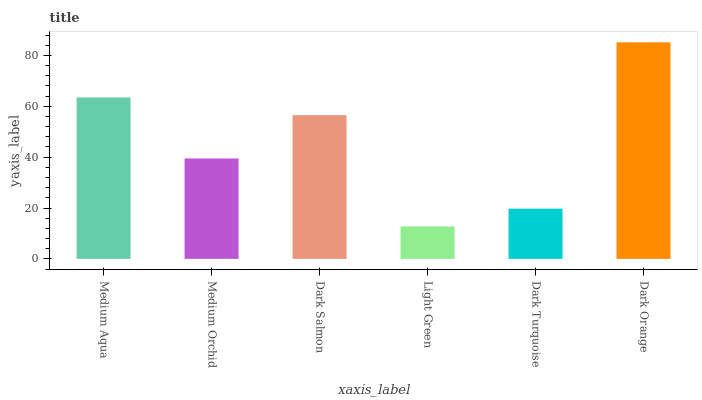Is Light Green the minimum?
Answer yes or no. Yes. Is Dark Orange the maximum?
Answer yes or no. Yes. Is Medium Orchid the minimum?
Answer yes or no. No. Is Medium Orchid the maximum?
Answer yes or no. No. Is Medium Aqua greater than Medium Orchid?
Answer yes or no. Yes. Is Medium Orchid less than Medium Aqua?
Answer yes or no. Yes. Is Medium Orchid greater than Medium Aqua?
Answer yes or no. No. Is Medium Aqua less than Medium Orchid?
Answer yes or no. No. Is Dark Salmon the high median?
Answer yes or no. Yes. Is Medium Orchid the low median?
Answer yes or no. Yes. Is Medium Orchid the high median?
Answer yes or no. No. Is Medium Aqua the low median?
Answer yes or no. No. 